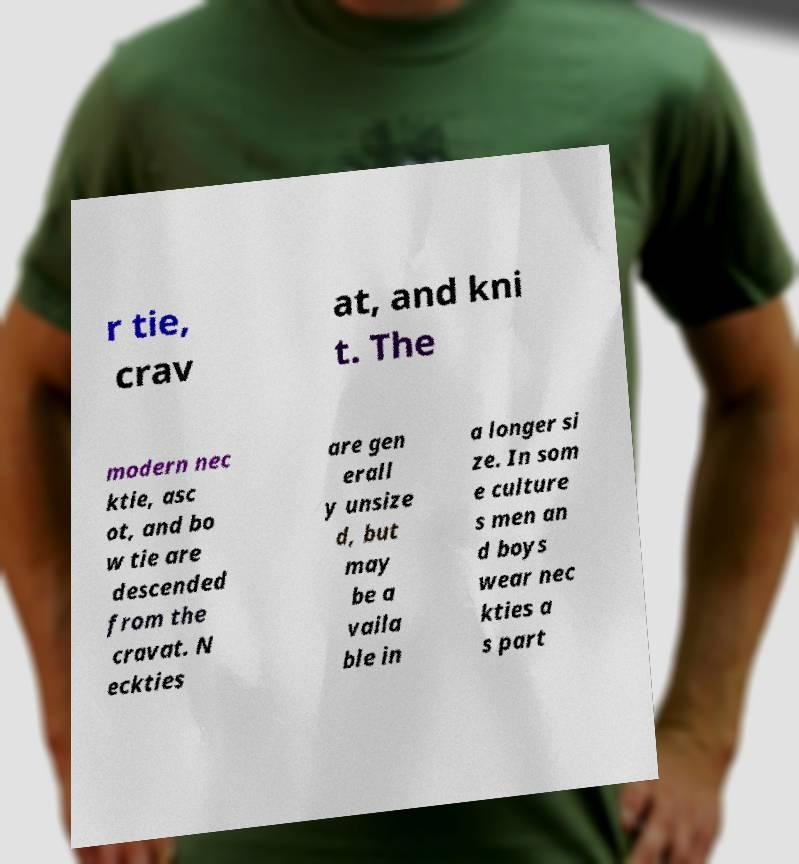I need the written content from this picture converted into text. Can you do that? r tie, crav at, and kni t. The modern nec ktie, asc ot, and bo w tie are descended from the cravat. N eckties are gen erall y unsize d, but may be a vaila ble in a longer si ze. In som e culture s men an d boys wear nec kties a s part 